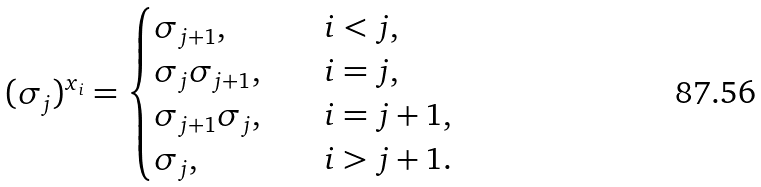Convert formula to latex. <formula><loc_0><loc_0><loc_500><loc_500>( \sigma _ { j } ) ^ { x _ { i } } = \begin{cases} \sigma _ { j + 1 } , \quad & i < j , \\ \sigma _ { j } \sigma _ { j + 1 } , \quad & i = j , \\ \sigma _ { j + 1 } \sigma _ { j } , \quad & i = j + 1 , \\ \sigma _ { j } , \quad & i > j + 1 . \end{cases}</formula> 